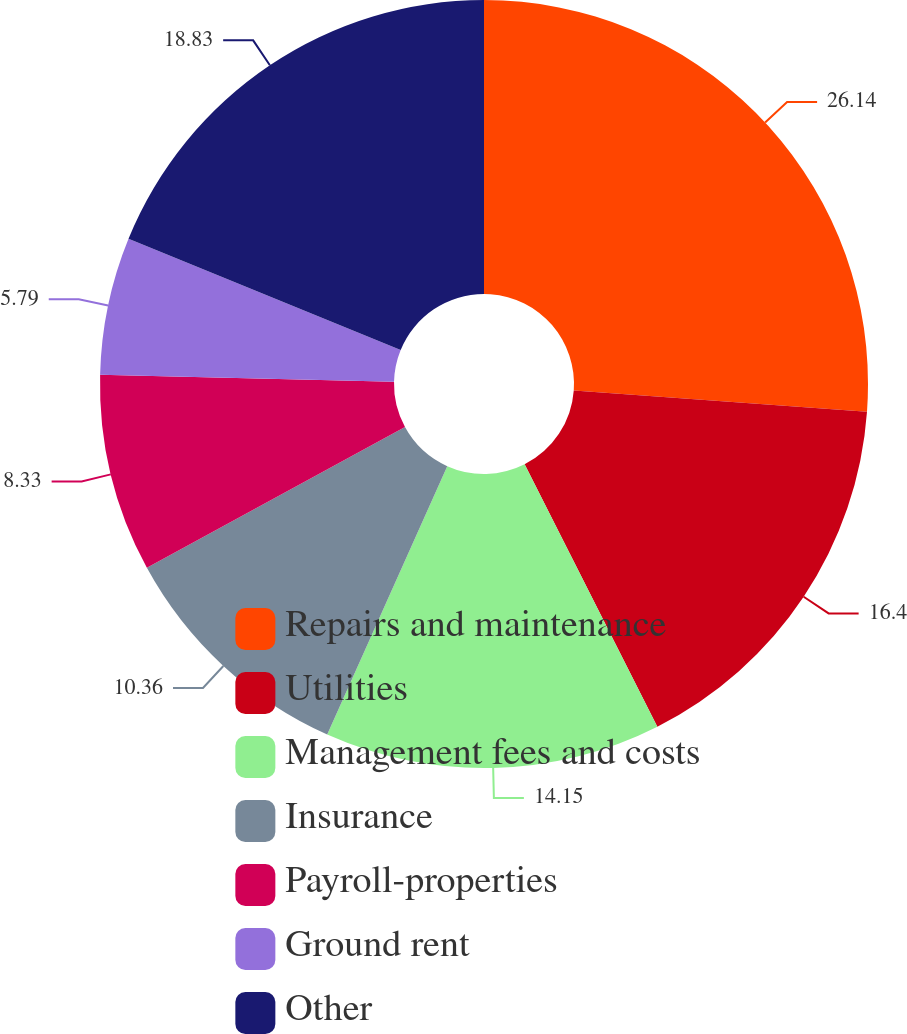Convert chart. <chart><loc_0><loc_0><loc_500><loc_500><pie_chart><fcel>Repairs and maintenance<fcel>Utilities<fcel>Management fees and costs<fcel>Insurance<fcel>Payroll-properties<fcel>Ground rent<fcel>Other<nl><fcel>26.15%<fcel>16.4%<fcel>14.15%<fcel>10.36%<fcel>8.33%<fcel>5.79%<fcel>18.83%<nl></chart> 